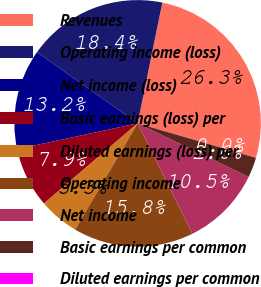<chart> <loc_0><loc_0><loc_500><loc_500><pie_chart><fcel>Revenues<fcel>Operating income (loss)<fcel>Net income (loss)<fcel>Basic earnings (loss) per<fcel>Diluted earnings (loss) per<fcel>Operating income<fcel>Net income<fcel>Basic earnings per common<fcel>Diluted earnings per common<nl><fcel>26.31%<fcel>18.42%<fcel>13.16%<fcel>7.9%<fcel>5.27%<fcel>15.79%<fcel>10.53%<fcel>2.63%<fcel>0.0%<nl></chart> 